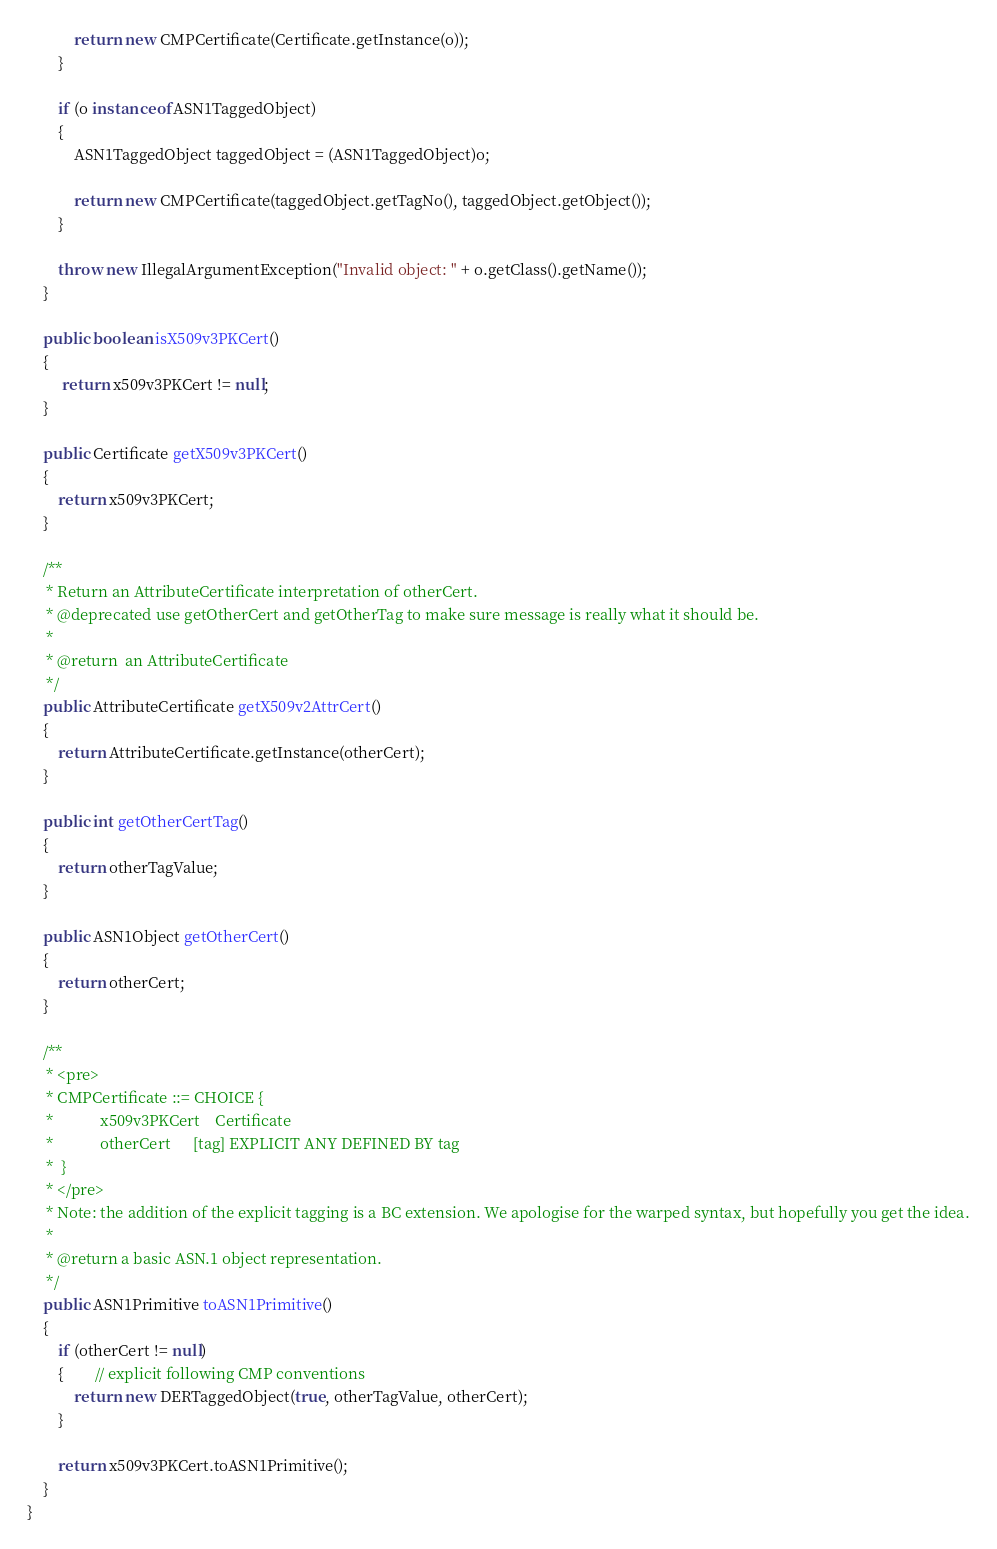Convert code to text. <code><loc_0><loc_0><loc_500><loc_500><_Java_>            return new CMPCertificate(Certificate.getInstance(o));
        }

        if (o instanceof ASN1TaggedObject)
        {
            ASN1TaggedObject taggedObject = (ASN1TaggedObject)o;

            return new CMPCertificate(taggedObject.getTagNo(), taggedObject.getObject());
        }

        throw new IllegalArgumentException("Invalid object: " + o.getClass().getName());
    }

    public boolean isX509v3PKCert()
    {
         return x509v3PKCert != null;
    }

    public Certificate getX509v3PKCert()
    {
        return x509v3PKCert;
    }

    /**
     * Return an AttributeCertificate interpretation of otherCert.
     * @deprecated use getOtherCert and getOtherTag to make sure message is really what it should be.
     *
     * @return  an AttributeCertificate
     */
    public AttributeCertificate getX509v2AttrCert()
    {
        return AttributeCertificate.getInstance(otherCert);
    }

    public int getOtherCertTag()
    {
        return otherTagValue;
    }

    public ASN1Object getOtherCert()
    {
        return otherCert;
    }

    /**
     * <pre>
     * CMPCertificate ::= CHOICE {
     *            x509v3PKCert    Certificate
     *            otherCert      [tag] EXPLICIT ANY DEFINED BY tag
     *  }
     * </pre>
     * Note: the addition of the explicit tagging is a BC extension. We apologise for the warped syntax, but hopefully you get the idea.
     *
     * @return a basic ASN.1 object representation.
     */
    public ASN1Primitive toASN1Primitive()
    {
        if (otherCert != null)
        {        // explicit following CMP conventions
            return new DERTaggedObject(true, otherTagValue, otherCert);
        }

        return x509v3PKCert.toASN1Primitive();
    }
}
</code> 